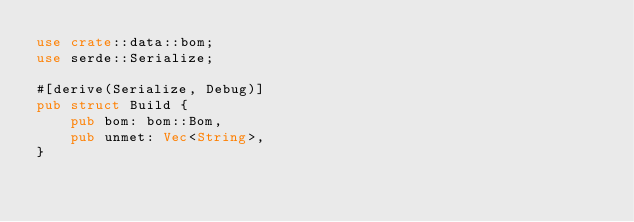Convert code to text. <code><loc_0><loc_0><loc_500><loc_500><_Rust_>use crate::data::bom;
use serde::Serialize;

#[derive(Serialize, Debug)]
pub struct Build {
    pub bom: bom::Bom,
    pub unmet: Vec<String>,
}
</code> 